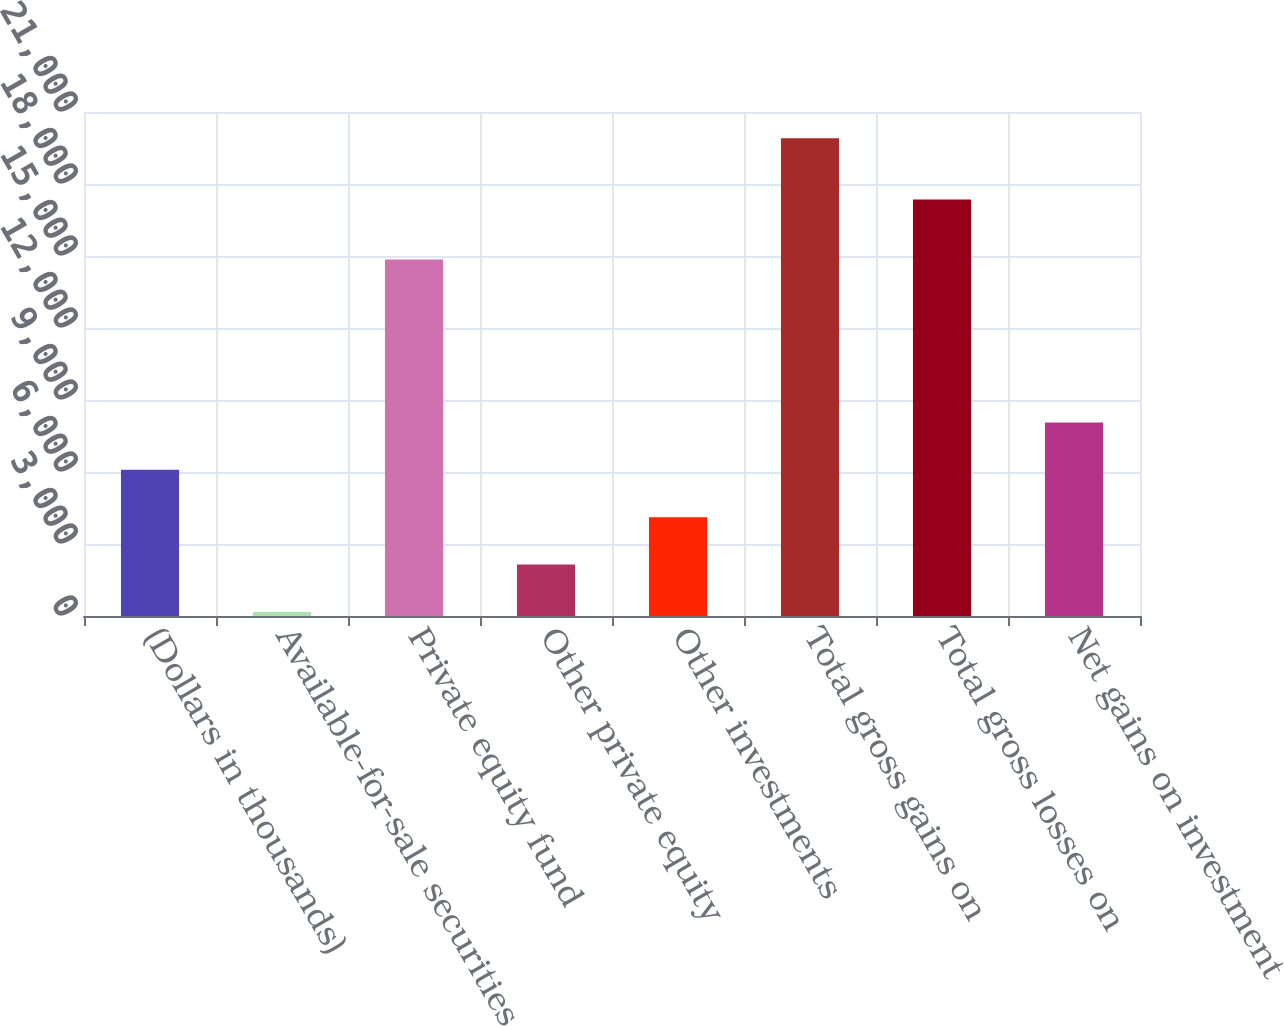Convert chart. <chart><loc_0><loc_0><loc_500><loc_500><bar_chart><fcel>(Dollars in thousands)<fcel>Available-for-sale securities<fcel>Private equity fund<fcel>Other private equity<fcel>Other investments<fcel>Total gross gains on<fcel>Total gross losses on<fcel>Net gains on investment<nl><fcel>6091.3<fcel>169<fcel>14853<fcel>2143.1<fcel>4117.2<fcel>19910<fcel>17359<fcel>8065.4<nl></chart> 